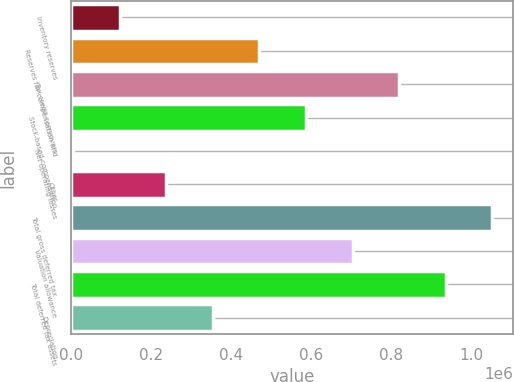<chart> <loc_0><loc_0><loc_500><loc_500><bar_chart><fcel>Inventory reserves<fcel>Reserves for compensation and<fcel>Tax credit carryovers<fcel>Stock-based compensation<fcel>Net operating losses<fcel>Other<fcel>Total gross deferred tax<fcel>Valuation allowance<fcel>Total deferred tax assets<fcel>Depreciation<nl><fcel>122266<fcel>471072<fcel>819878<fcel>587340<fcel>5997<fcel>238534<fcel>1.05242e+06<fcel>703609<fcel>936147<fcel>354803<nl></chart> 